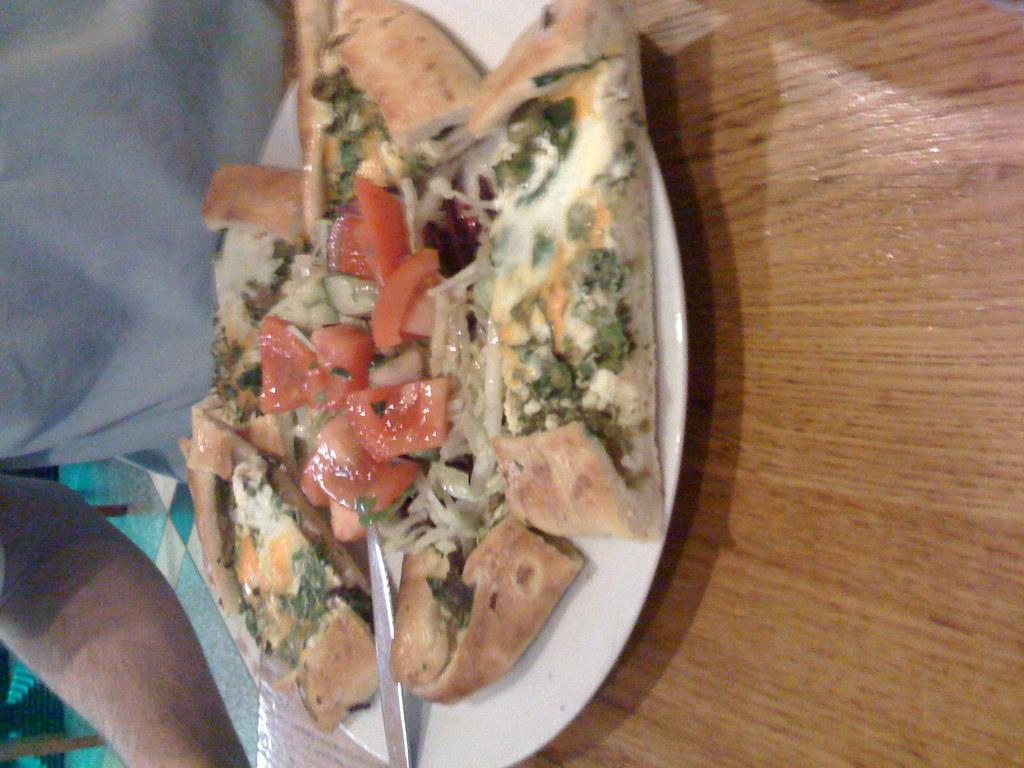What is on the plate in the image? There is food in a plate in the image. What utensil is visible in the image? There is a spoon in the image. Where is the spoon placed? The spoon is on a wooden table. Can you describe the person in the image? There is a person in the image, but no specific details are provided about their appearance or actions. What type of vase can be seen on the grass in the image? There is no vase or grass present in the image; it only features food on a plate, a spoon, and a wooden table. 